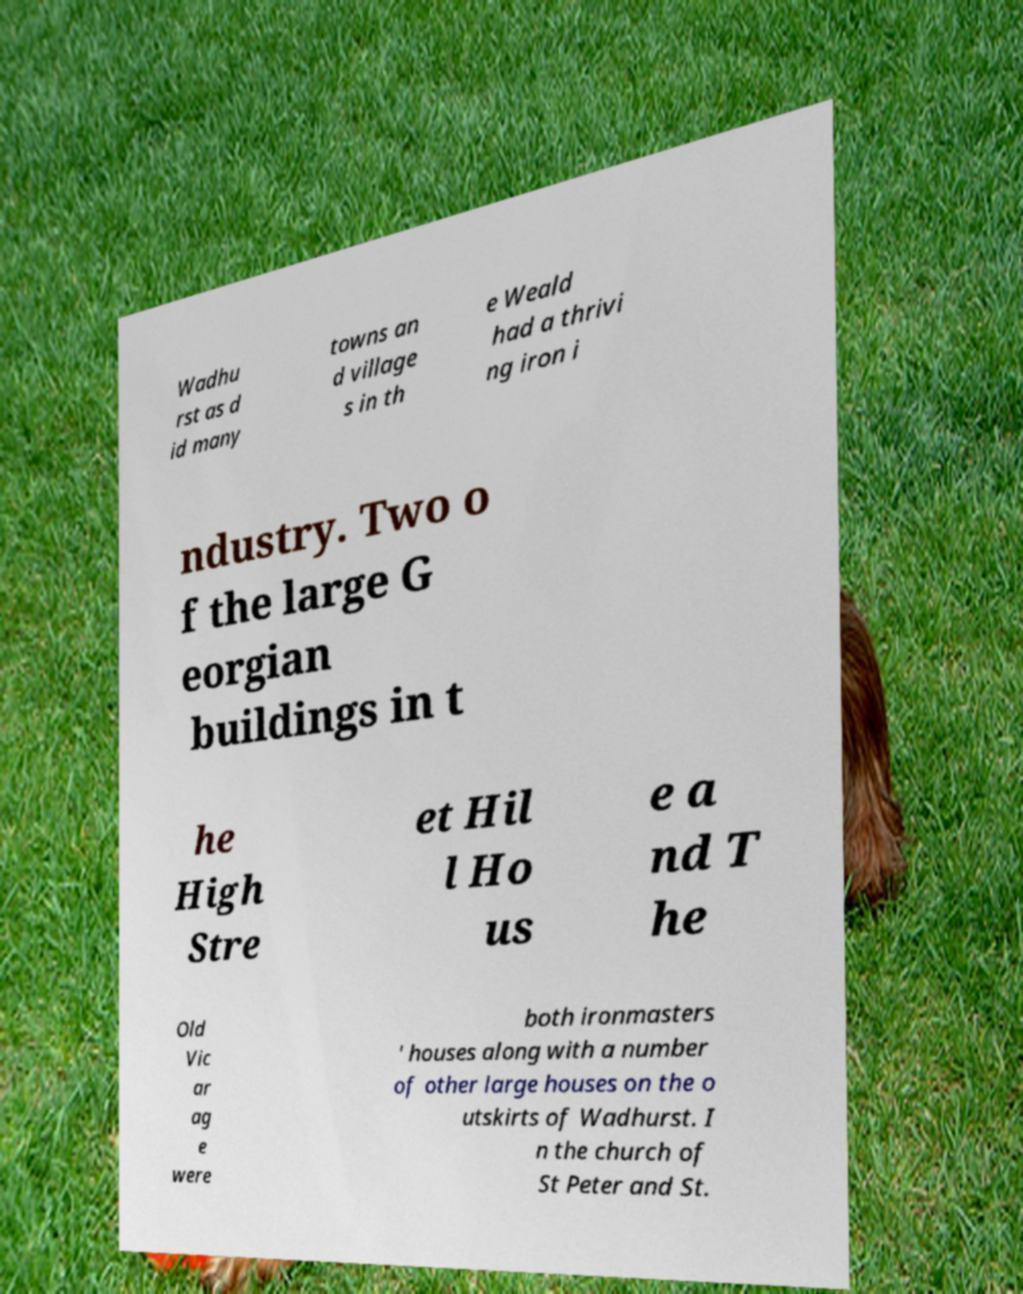What messages or text are displayed in this image? I need them in a readable, typed format. Wadhu rst as d id many towns an d village s in th e Weald had a thrivi ng iron i ndustry. Two o f the large G eorgian buildings in t he High Stre et Hil l Ho us e a nd T he Old Vic ar ag e were both ironmasters ' houses along with a number of other large houses on the o utskirts of Wadhurst. I n the church of St Peter and St. 